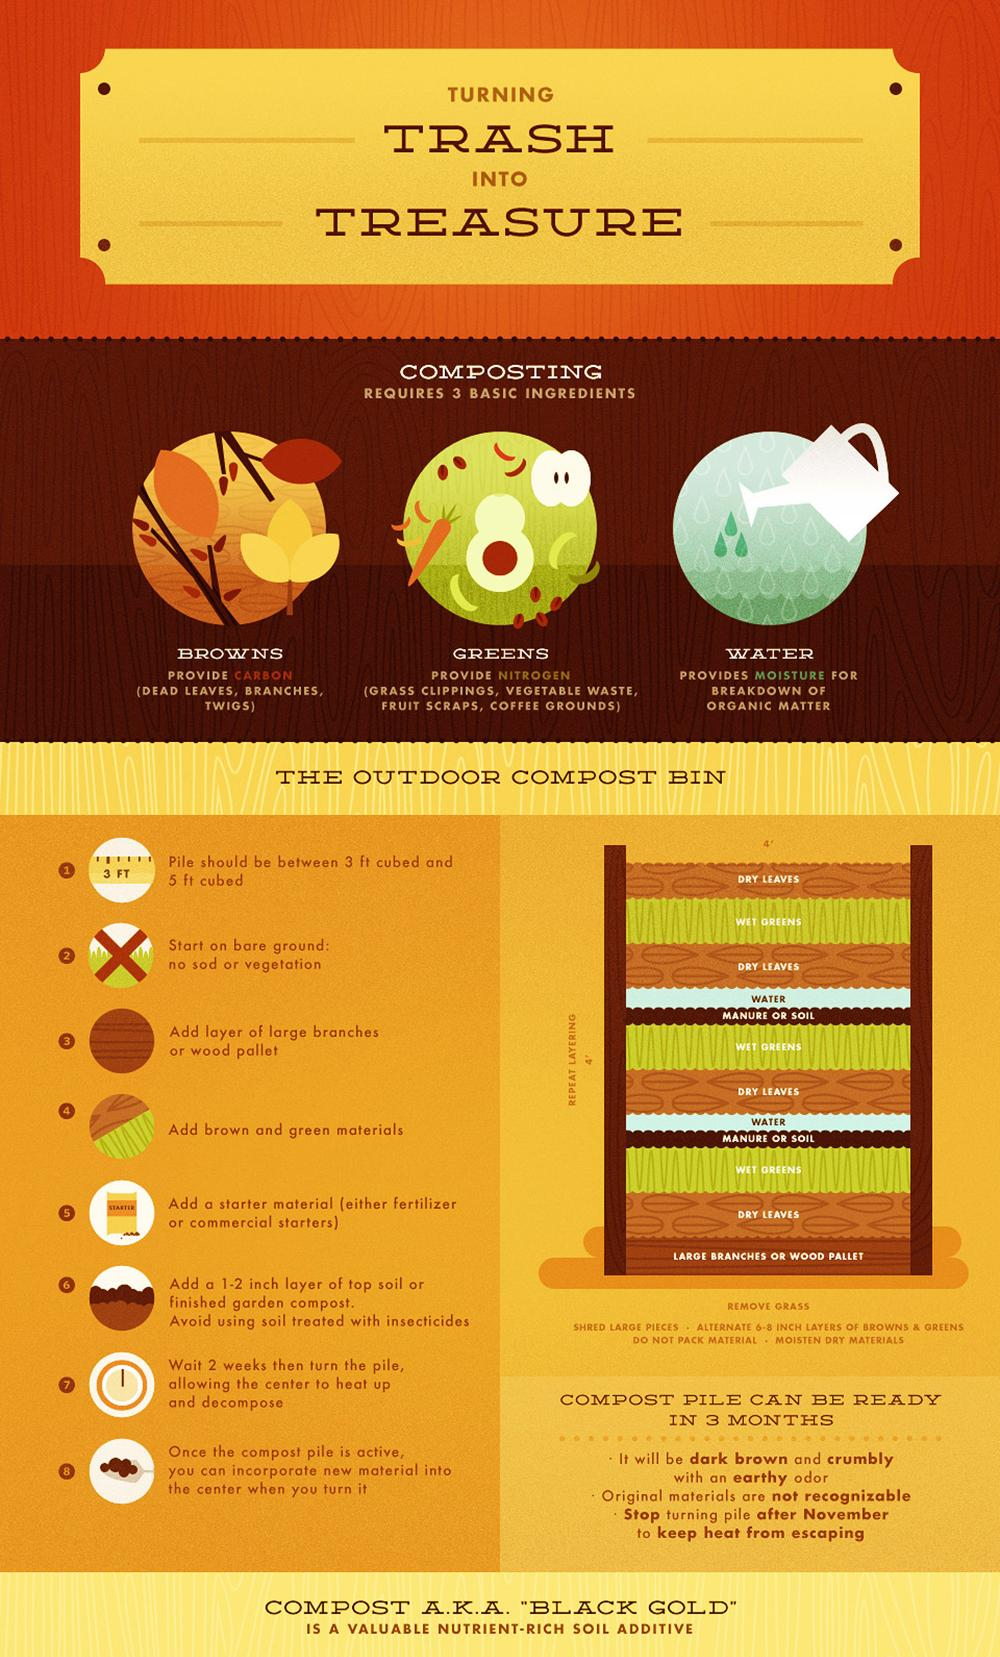Mention a couple of crucial points in this snapshot. Examples of Browns include dead leaves, branches, and twigs. Compost is created by combining a specific set of basic ingredients, including browns and greens, and maintaining proper water levels. The green layer of compost is shown to be wet. The compost emits an earthy and pungent odor. List 3 examples of Greens: Grass clippings, vegetable waste, and fruit scraps. 